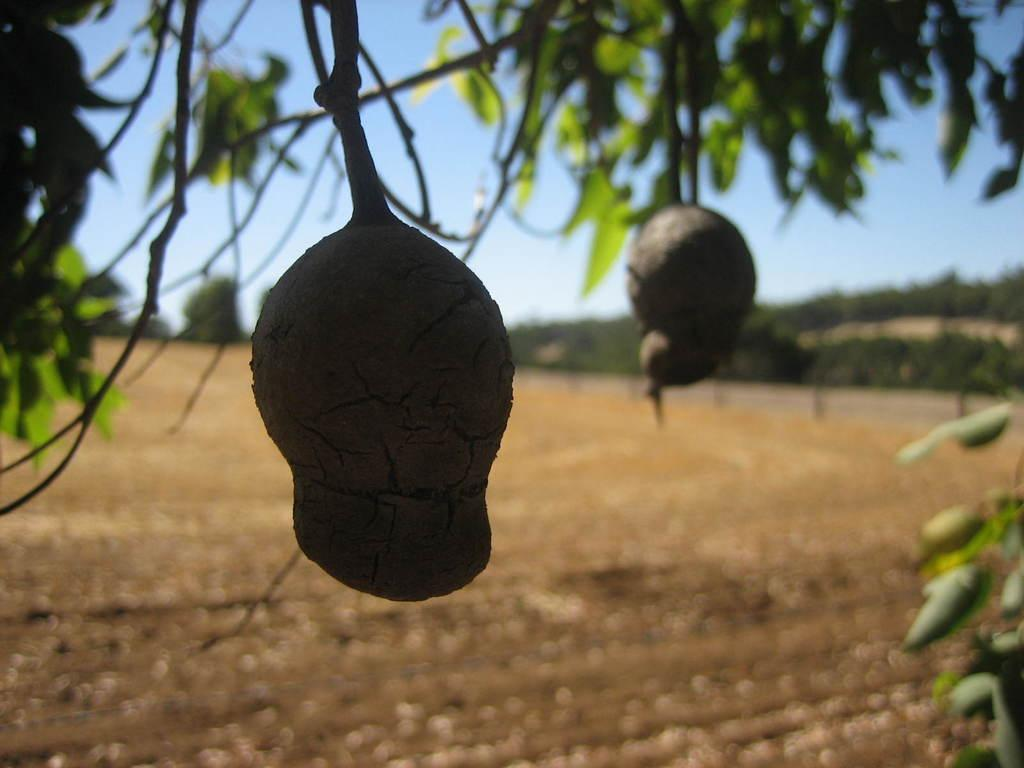What is located on the tree in the image? There is a fruit or vegetable on a tree in the image. How is the background of the tree depicted? The background of the tree is blurred. What type of stage can be seen in the background of the image? There is no stage present in the image; it features a tree with a fruit or vegetable and a blurred background. How many eyes are visible on the tree in the image? There are no eyes visible on the tree in the image; it features a fruit or vegetable and a blurred background. 